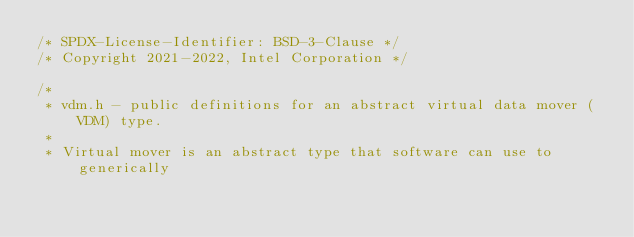<code> <loc_0><loc_0><loc_500><loc_500><_C_>/* SPDX-License-Identifier: BSD-3-Clause */
/* Copyright 2021-2022, Intel Corporation */

/*
 * vdm.h - public definitions for an abstract virtual data mover (VDM) type.
 *
 * Virtual mover is an abstract type that software can use to generically</code> 